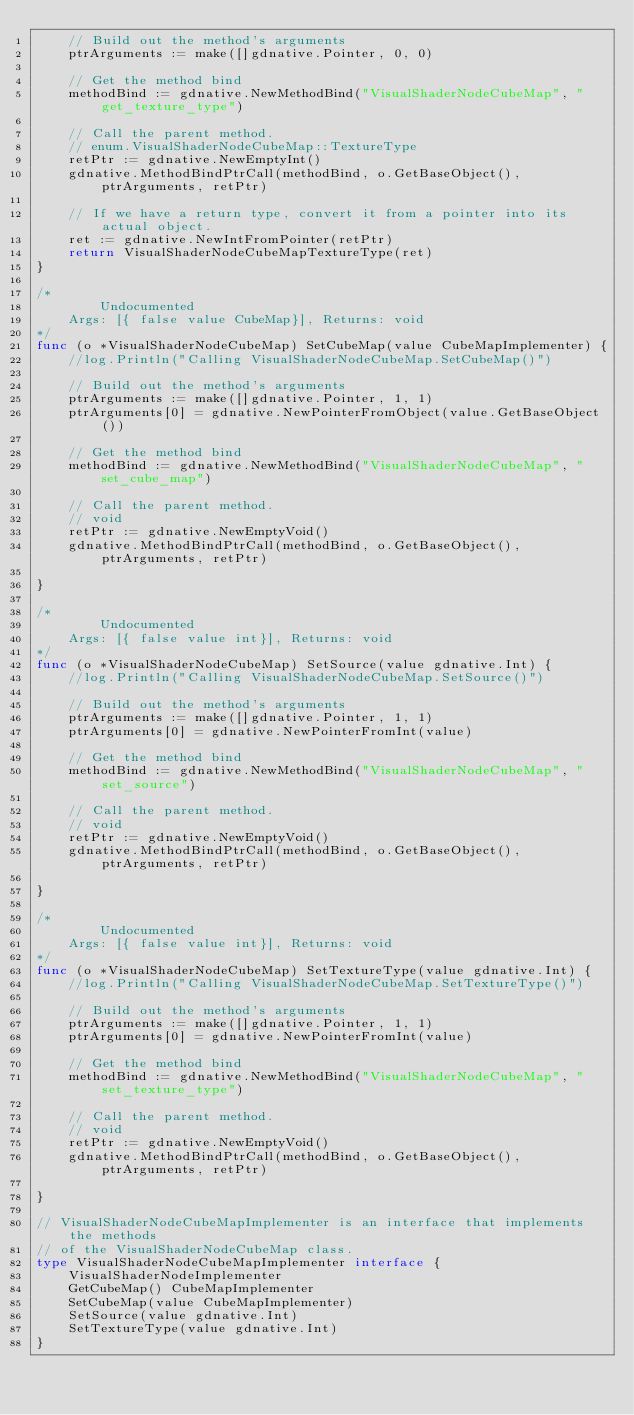Convert code to text. <code><loc_0><loc_0><loc_500><loc_500><_Go_>	// Build out the method's arguments
	ptrArguments := make([]gdnative.Pointer, 0, 0)

	// Get the method bind
	methodBind := gdnative.NewMethodBind("VisualShaderNodeCubeMap", "get_texture_type")

	// Call the parent method.
	// enum.VisualShaderNodeCubeMap::TextureType
	retPtr := gdnative.NewEmptyInt()
	gdnative.MethodBindPtrCall(methodBind, o.GetBaseObject(), ptrArguments, retPtr)

	// If we have a return type, convert it from a pointer into its actual object.
	ret := gdnative.NewIntFromPointer(retPtr)
	return VisualShaderNodeCubeMapTextureType(ret)
}

/*
        Undocumented
	Args: [{ false value CubeMap}], Returns: void
*/
func (o *VisualShaderNodeCubeMap) SetCubeMap(value CubeMapImplementer) {
	//log.Println("Calling VisualShaderNodeCubeMap.SetCubeMap()")

	// Build out the method's arguments
	ptrArguments := make([]gdnative.Pointer, 1, 1)
	ptrArguments[0] = gdnative.NewPointerFromObject(value.GetBaseObject())

	// Get the method bind
	methodBind := gdnative.NewMethodBind("VisualShaderNodeCubeMap", "set_cube_map")

	// Call the parent method.
	// void
	retPtr := gdnative.NewEmptyVoid()
	gdnative.MethodBindPtrCall(methodBind, o.GetBaseObject(), ptrArguments, retPtr)

}

/*
        Undocumented
	Args: [{ false value int}], Returns: void
*/
func (o *VisualShaderNodeCubeMap) SetSource(value gdnative.Int) {
	//log.Println("Calling VisualShaderNodeCubeMap.SetSource()")

	// Build out the method's arguments
	ptrArguments := make([]gdnative.Pointer, 1, 1)
	ptrArguments[0] = gdnative.NewPointerFromInt(value)

	// Get the method bind
	methodBind := gdnative.NewMethodBind("VisualShaderNodeCubeMap", "set_source")

	// Call the parent method.
	// void
	retPtr := gdnative.NewEmptyVoid()
	gdnative.MethodBindPtrCall(methodBind, o.GetBaseObject(), ptrArguments, retPtr)

}

/*
        Undocumented
	Args: [{ false value int}], Returns: void
*/
func (o *VisualShaderNodeCubeMap) SetTextureType(value gdnative.Int) {
	//log.Println("Calling VisualShaderNodeCubeMap.SetTextureType()")

	// Build out the method's arguments
	ptrArguments := make([]gdnative.Pointer, 1, 1)
	ptrArguments[0] = gdnative.NewPointerFromInt(value)

	// Get the method bind
	methodBind := gdnative.NewMethodBind("VisualShaderNodeCubeMap", "set_texture_type")

	// Call the parent method.
	// void
	retPtr := gdnative.NewEmptyVoid()
	gdnative.MethodBindPtrCall(methodBind, o.GetBaseObject(), ptrArguments, retPtr)

}

// VisualShaderNodeCubeMapImplementer is an interface that implements the methods
// of the VisualShaderNodeCubeMap class.
type VisualShaderNodeCubeMapImplementer interface {
	VisualShaderNodeImplementer
	GetCubeMap() CubeMapImplementer
	SetCubeMap(value CubeMapImplementer)
	SetSource(value gdnative.Int)
	SetTextureType(value gdnative.Int)
}
</code> 